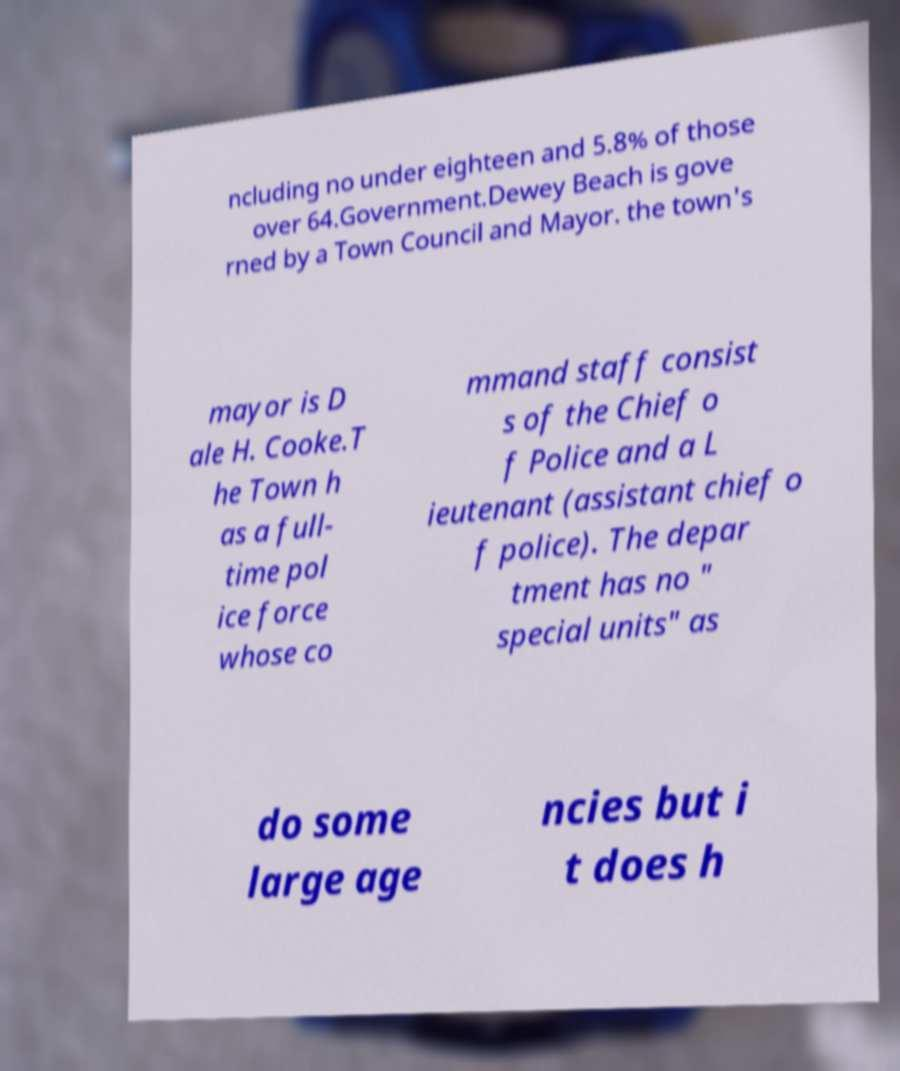Could you assist in decoding the text presented in this image and type it out clearly? ncluding no under eighteen and 5.8% of those over 64.Government.Dewey Beach is gove rned by a Town Council and Mayor. the town's mayor is D ale H. Cooke.T he Town h as a full- time pol ice force whose co mmand staff consist s of the Chief o f Police and a L ieutenant (assistant chief o f police). The depar tment has no " special units" as do some large age ncies but i t does h 